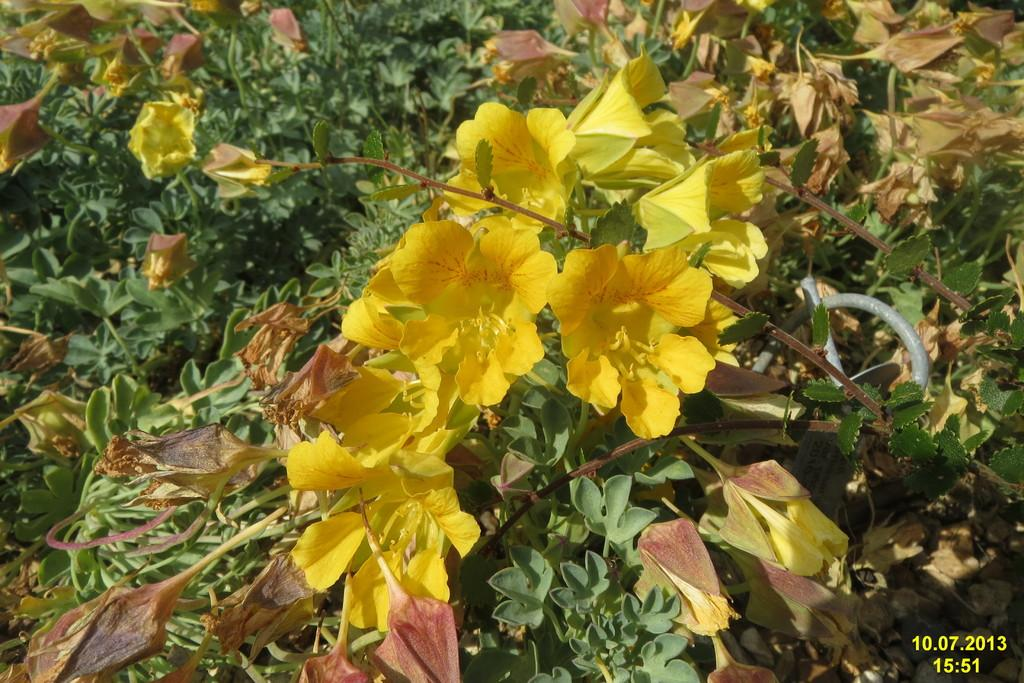What type of living organisms can be seen in the image? There are flowers and plants visible in the image. Can you describe the text at the bottom of the image? Unfortunately, the provided facts do not give any information about the text at the bottom of the image. What is the primary focus of the image? The primary focus of the image appears to be the flowers and plants. What type of brick is being used to build the army barracks in the image? There is no brick or army barracks present in the image; it features flowers and plants. What type of produce is being harvested in the image? There is no produce or harvesting activity present in the image; it features flowers and plants. 